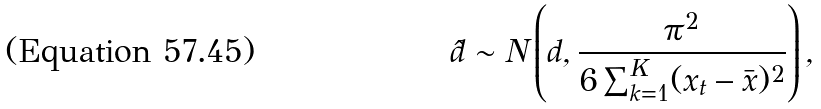<formula> <loc_0><loc_0><loc_500><loc_500>\hat { d } \sim N \left ( d , \frac { \pi ^ { 2 } } { 6 \sum _ { k = 1 } ^ { K } ( x _ { t } - \bar { x } ) ^ { 2 } } \right ) ,</formula> 